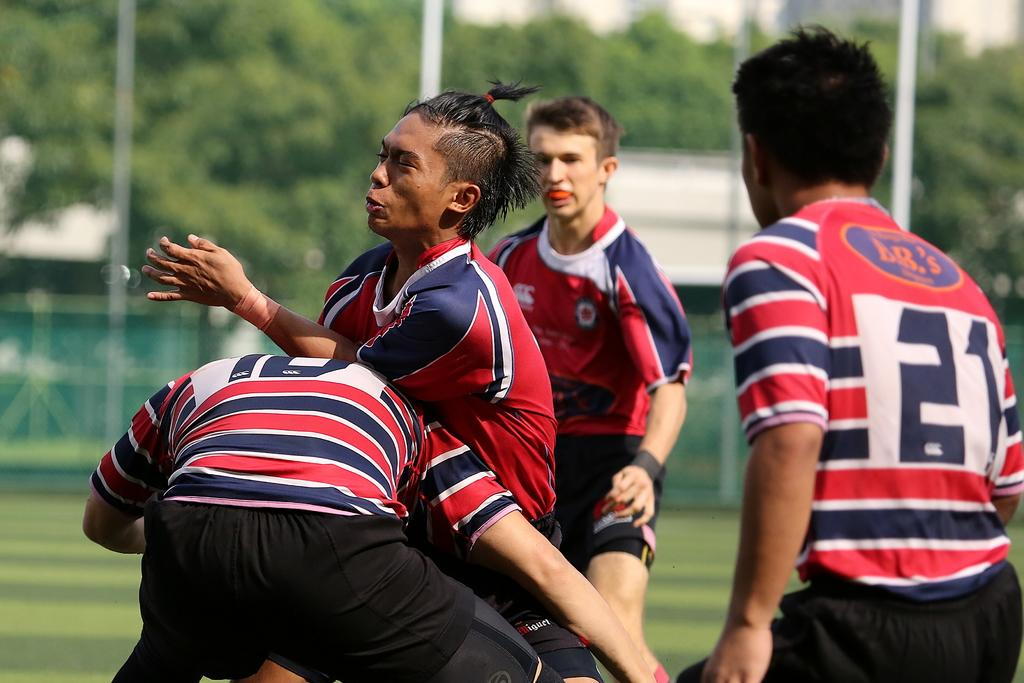How many people are present in the image? There are four people in the image. What are two of the people doing in the image? Two of the people appear to be fighting. What can be seen in the background of the image? There are trees in the background of the image. What type of worm can be seen crawling on the sister's shoulder in the image? There is no sister or worm present in the image. 